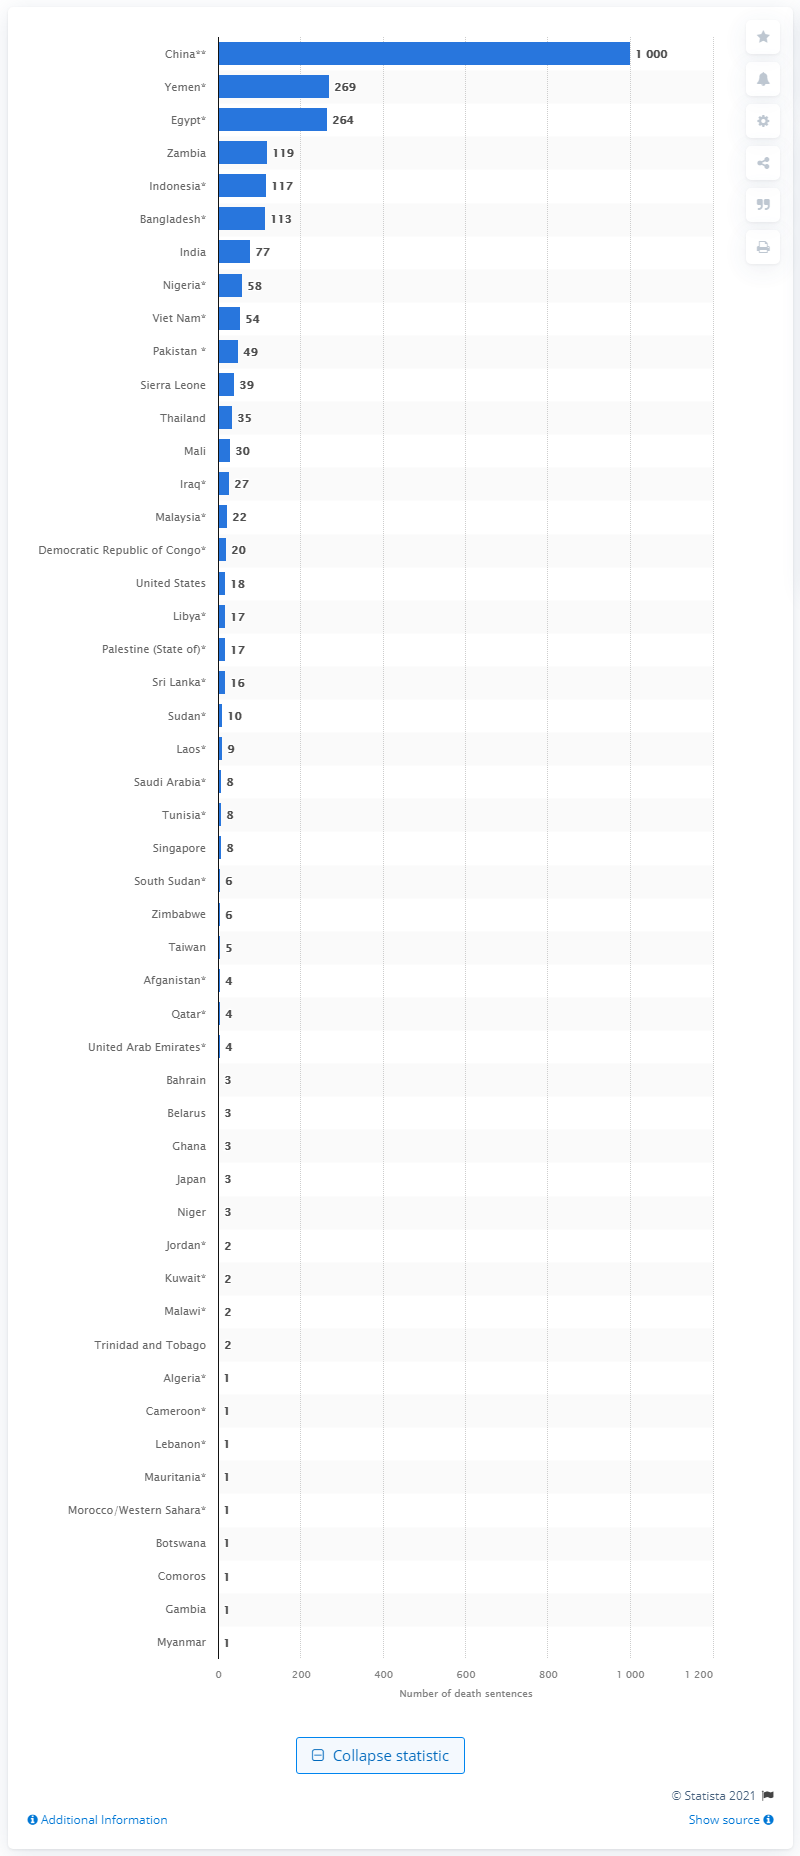Give some essential details in this illustration. In 2020, 269 individuals were sentenced to death in Yemen. 